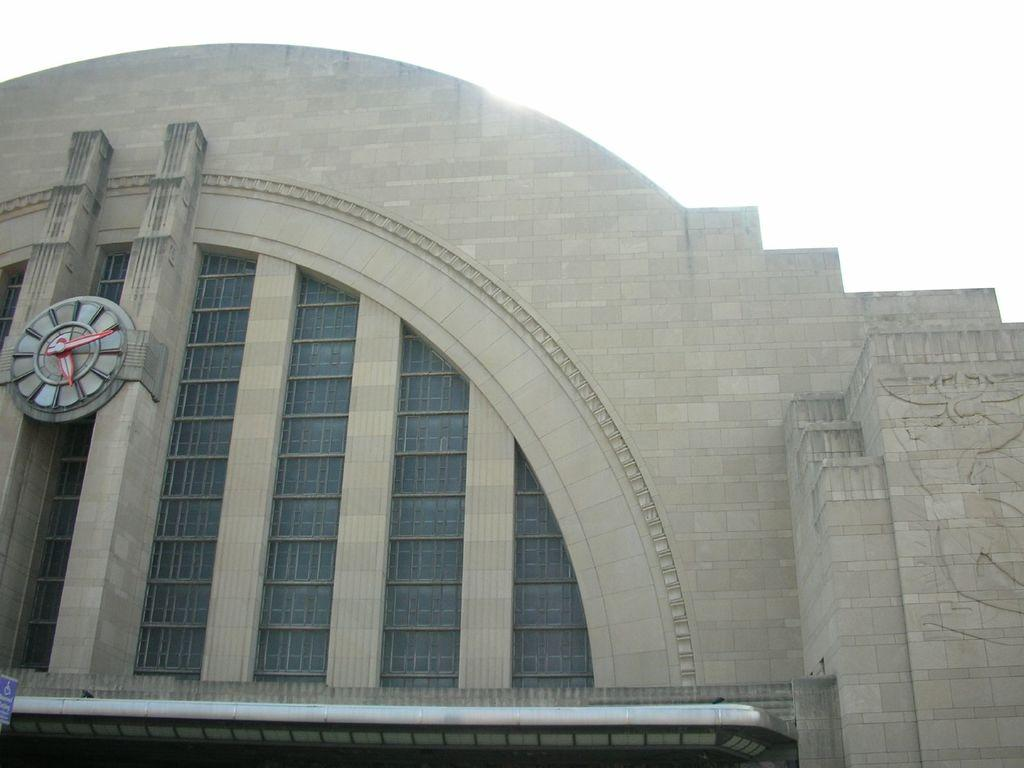What type of structure is visible in the image? There is a building in the image. What can be found on the building in the image? There is a clock and a sign board visible on the building. What type of suit can be seen hanging in the building in the image? There is no suit visible in the image; only a building, clock, and sign board are present. 